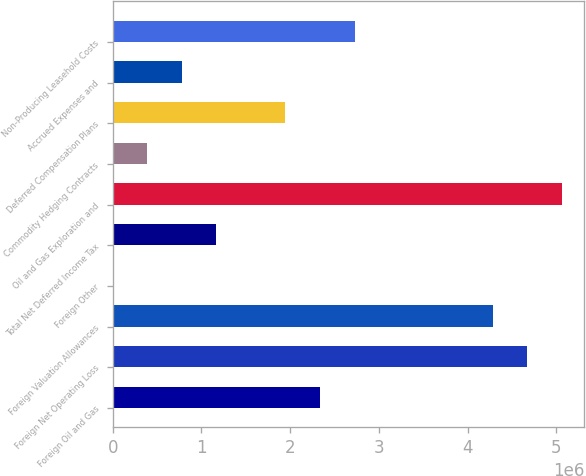Convert chart to OTSL. <chart><loc_0><loc_0><loc_500><loc_500><bar_chart><fcel>Foreign Oil and Gas<fcel>Foreign Net Operating Loss<fcel>Foreign Valuation Allowances<fcel>Foreign Other<fcel>Total Net Deferred Income Tax<fcel>Oil and Gas Exploration and<fcel>Commodity Hedging Contracts<fcel>Deferred Compensation Plans<fcel>Accrued Expenses and<fcel>Non-Producing Leasehold Costs<nl><fcel>2.33703e+06<fcel>4.67359e+06<fcel>4.28417e+06<fcel>478<fcel>1.16876e+06<fcel>5.06302e+06<fcel>389904<fcel>1.94761e+06<fcel>779330<fcel>2.72646e+06<nl></chart> 